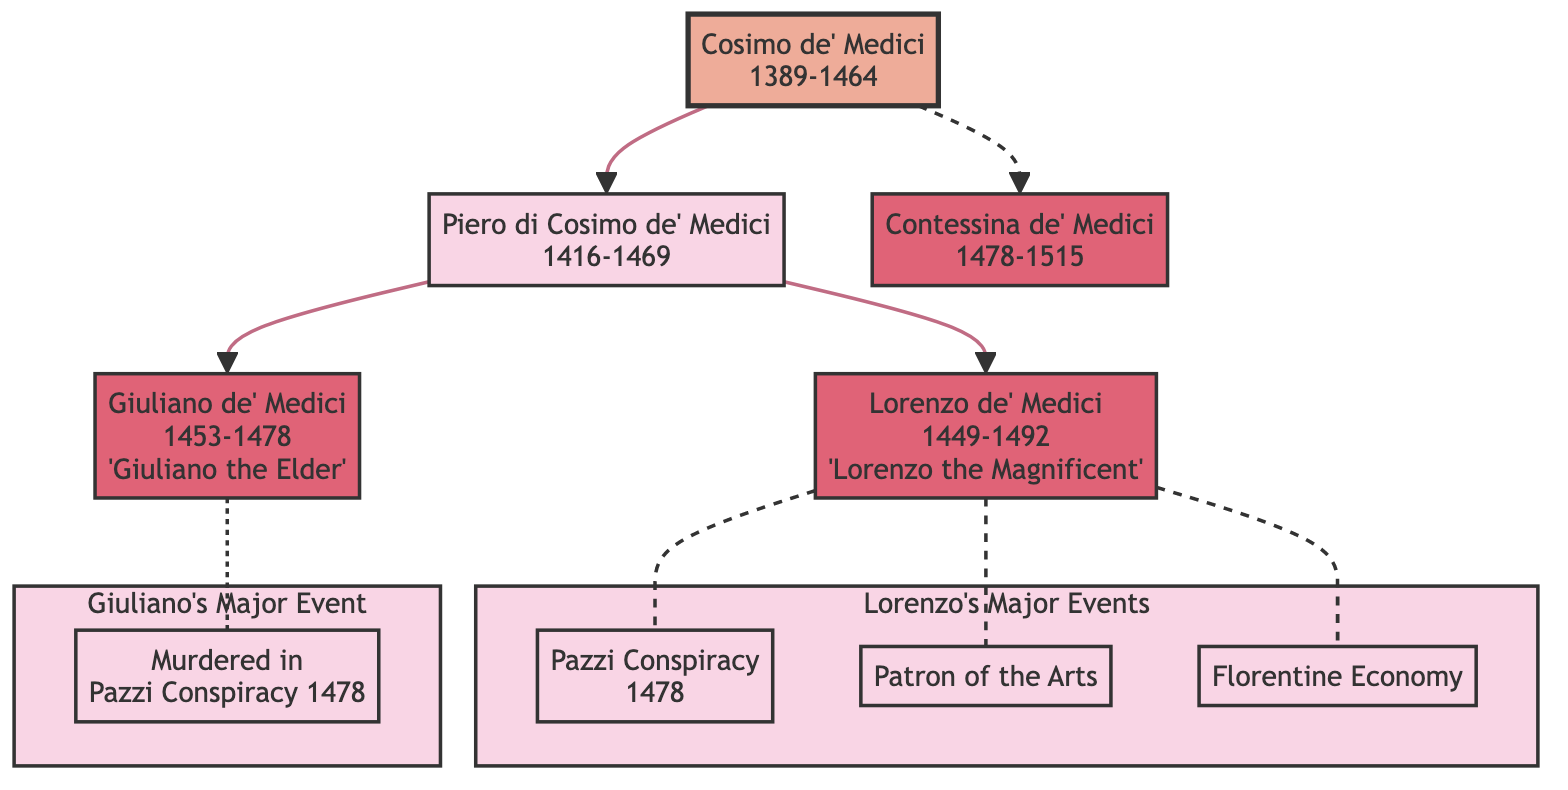What is the name of Cosimo de' Medici's son? The diagram shows that Piero di Cosimo de' Medici is listed directly under Cosimo de' Medici, indicating his relationship as his son.
Answer: Piero di Cosimo de' Medici How many children did Piero di Cosimo de' Medici have? In the diagram, Piero has two children depicted as nodes: Lorenzo de' Medici and Giuliano de' Medici.
Answer: 2 What major event is associated with Lorenzo de' Medici? The diagram connects Lorenzo to three major events. The first listed is the Pazzi Conspiracy of 1478.
Answer: Pazzi Conspiracy Which member was murdered during the Pazzi Conspiracy? The diagram indicates that Giuliano de' Medici was murdered in the Pazzi Conspiracy in 1478, as it is noted next to his name.
Answer: Giuliano de' Medici How many generations of the Medici family are shown in the diagram? The diagram outlines three generations: Cosimo, Piero, and then Lorenzo and Giuliano, plus Contessina. Counting these gives three distinct generations.
Answer: 3 Who is known as Lorenzo the Magnificent? The diagram specifies that Lorenzo de' Medici is referred to as Lorenzo the Magnificent, as indicated in the attributes section beneath his name.
Answer: Lorenzo de' Medici What relationship does Contessina de' Medici have with Cosimo de' Medici? The diagram illustrates that Contessina is a descendant of Cosimo, as she is connected directly to him, indicating her status as his descendant.
Answer: Daughter What connects Piero di Cosimo de' Medici to Lorenzo de' Medici? The diagram directly links Piero to Lorenzo as his child, showing a father-son relationship through the hierarchical structure.
Answer: Father-Son What major role did Lorenzo take on concerning the arts? According to the diagram, one of Lorenzo's significant attributes is being a Patron of the Arts, showing his influence in this area.
Answer: Patron of the Arts 